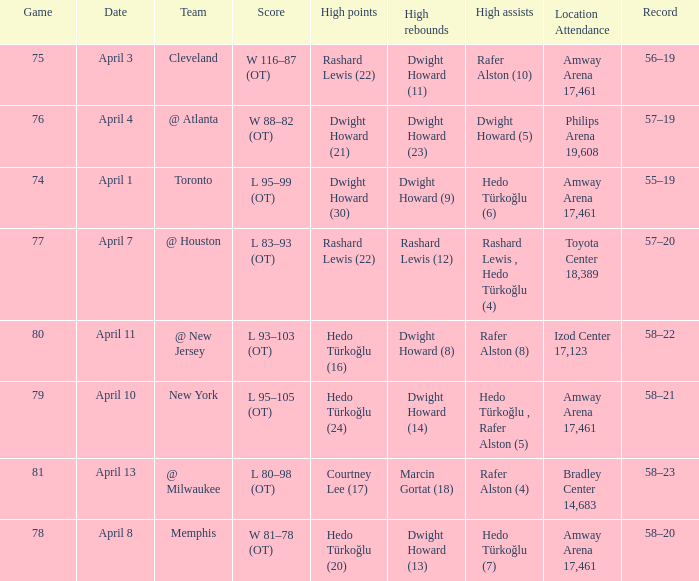What was the score in game 81? L 80–98 (OT). 